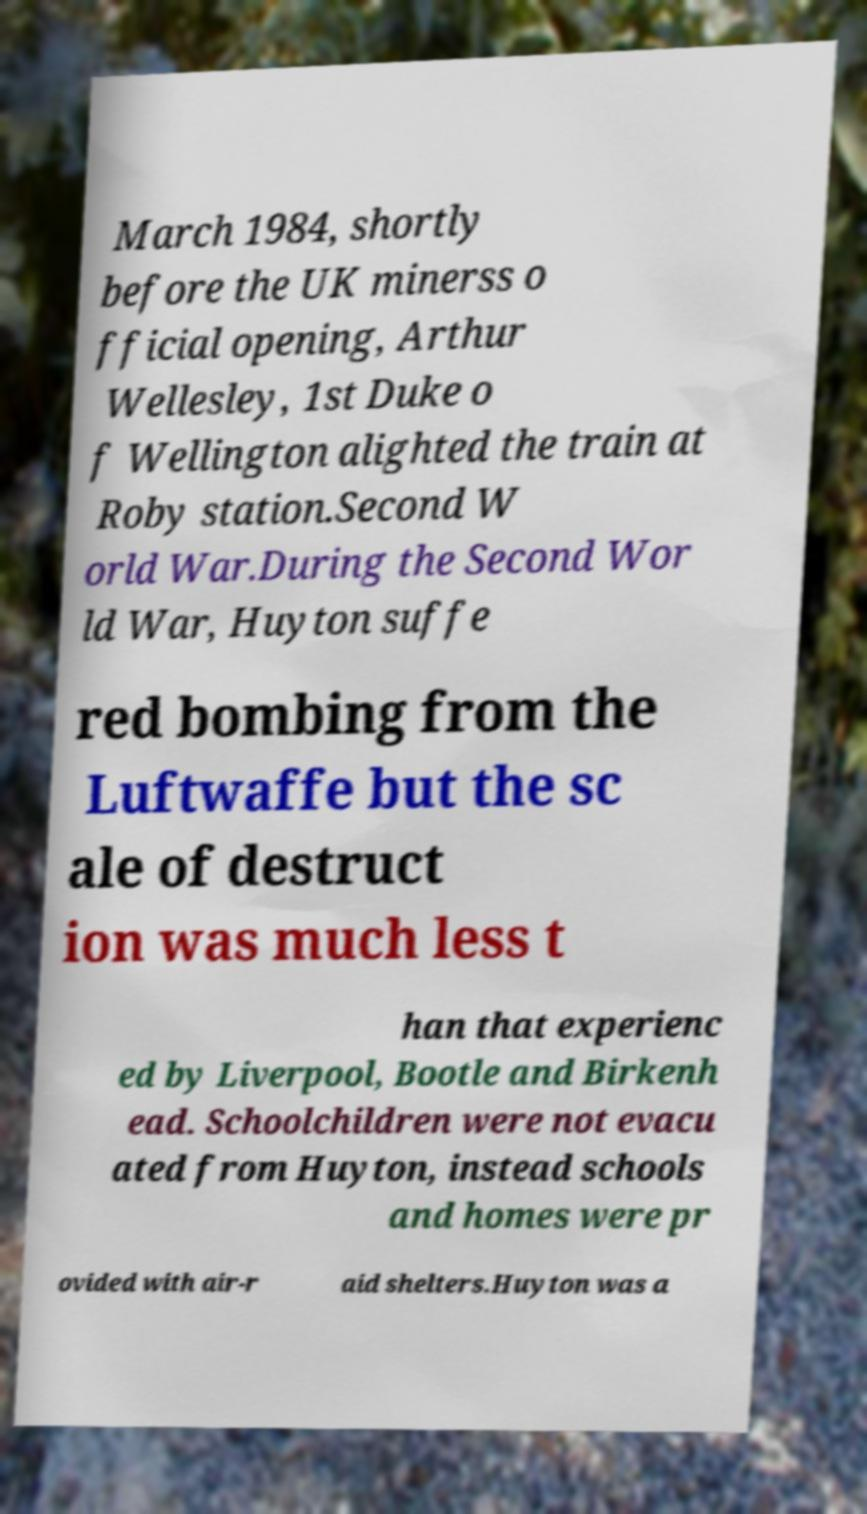Can you accurately transcribe the text from the provided image for me? March 1984, shortly before the UK minerss o fficial opening, Arthur Wellesley, 1st Duke o f Wellington alighted the train at Roby station.Second W orld War.During the Second Wor ld War, Huyton suffe red bombing from the Luftwaffe but the sc ale of destruct ion was much less t han that experienc ed by Liverpool, Bootle and Birkenh ead. Schoolchildren were not evacu ated from Huyton, instead schools and homes were pr ovided with air-r aid shelters.Huyton was a 